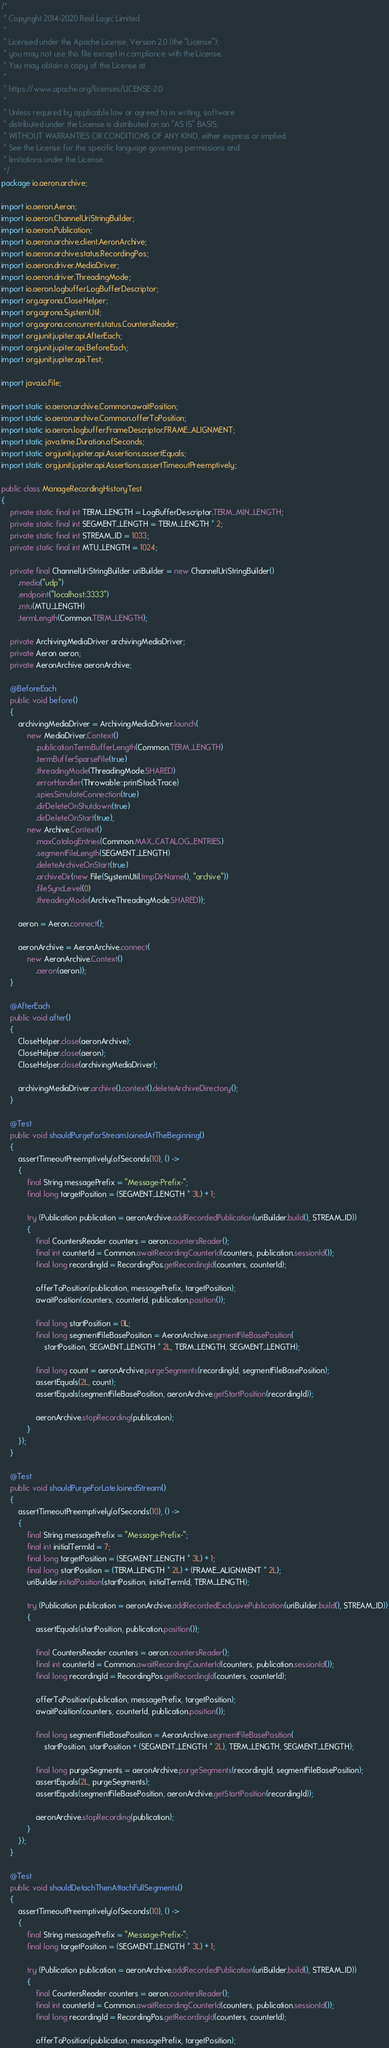Convert code to text. <code><loc_0><loc_0><loc_500><loc_500><_Java_>/*
 * Copyright 2014-2020 Real Logic Limited.
 *
 * Licensed under the Apache License, Version 2.0 (the "License");
 * you may not use this file except in compliance with the License.
 * You may obtain a copy of the License at
 *
 * https://www.apache.org/licenses/LICENSE-2.0
 *
 * Unless required by applicable law or agreed to in writing, software
 * distributed under the License is distributed on an "AS IS" BASIS,
 * WITHOUT WARRANTIES OR CONDITIONS OF ANY KIND, either express or implied.
 * See the License for the specific language governing permissions and
 * limitations under the License.
 */
package io.aeron.archive;

import io.aeron.Aeron;
import io.aeron.ChannelUriStringBuilder;
import io.aeron.Publication;
import io.aeron.archive.client.AeronArchive;
import io.aeron.archive.status.RecordingPos;
import io.aeron.driver.MediaDriver;
import io.aeron.driver.ThreadingMode;
import io.aeron.logbuffer.LogBufferDescriptor;
import org.agrona.CloseHelper;
import org.agrona.SystemUtil;
import org.agrona.concurrent.status.CountersReader;
import org.junit.jupiter.api.AfterEach;
import org.junit.jupiter.api.BeforeEach;
import org.junit.jupiter.api.Test;

import java.io.File;

import static io.aeron.archive.Common.awaitPosition;
import static io.aeron.archive.Common.offerToPosition;
import static io.aeron.logbuffer.FrameDescriptor.FRAME_ALIGNMENT;
import static java.time.Duration.ofSeconds;
import static org.junit.jupiter.api.Assertions.assertEquals;
import static org.junit.jupiter.api.Assertions.assertTimeoutPreemptively;

public class ManageRecordingHistoryTest
{
    private static final int TERM_LENGTH = LogBufferDescriptor.TERM_MIN_LENGTH;
    private static final int SEGMENT_LENGTH = TERM_LENGTH * 2;
    private static final int STREAM_ID = 1033;
    private static final int MTU_LENGTH = 1024;

    private final ChannelUriStringBuilder uriBuilder = new ChannelUriStringBuilder()
        .media("udp")
        .endpoint("localhost:3333")
        .mtu(MTU_LENGTH)
        .termLength(Common.TERM_LENGTH);

    private ArchivingMediaDriver archivingMediaDriver;
    private Aeron aeron;
    private AeronArchive aeronArchive;

    @BeforeEach
    public void before()
    {
        archivingMediaDriver = ArchivingMediaDriver.launch(
            new MediaDriver.Context()
                .publicationTermBufferLength(Common.TERM_LENGTH)
                .termBufferSparseFile(true)
                .threadingMode(ThreadingMode.SHARED)
                .errorHandler(Throwable::printStackTrace)
                .spiesSimulateConnection(true)
                .dirDeleteOnShutdown(true)
                .dirDeleteOnStart(true),
            new Archive.Context()
                .maxCatalogEntries(Common.MAX_CATALOG_ENTRIES)
                .segmentFileLength(SEGMENT_LENGTH)
                .deleteArchiveOnStart(true)
                .archiveDir(new File(SystemUtil.tmpDirName(), "archive"))
                .fileSyncLevel(0)
                .threadingMode(ArchiveThreadingMode.SHARED));

        aeron = Aeron.connect();

        aeronArchive = AeronArchive.connect(
            new AeronArchive.Context()
                .aeron(aeron));
    }

    @AfterEach
    public void after()
    {
        CloseHelper.close(aeronArchive);
        CloseHelper.close(aeron);
        CloseHelper.close(archivingMediaDriver);

        archivingMediaDriver.archive().context().deleteArchiveDirectory();
    }

    @Test
    public void shouldPurgeForStreamJoinedAtTheBeginning()
    {
        assertTimeoutPreemptively(ofSeconds(10), () ->
        {
            final String messagePrefix = "Message-Prefix-";
            final long targetPosition = (SEGMENT_LENGTH * 3L) + 1;

            try (Publication publication = aeronArchive.addRecordedPublication(uriBuilder.build(), STREAM_ID))
            {
                final CountersReader counters = aeron.countersReader();
                final int counterId = Common.awaitRecordingCounterId(counters, publication.sessionId());
                final long recordingId = RecordingPos.getRecordingId(counters, counterId);

                offerToPosition(publication, messagePrefix, targetPosition);
                awaitPosition(counters, counterId, publication.position());

                final long startPosition = 0L;
                final long segmentFileBasePosition = AeronArchive.segmentFileBasePosition(
                    startPosition, SEGMENT_LENGTH * 2L, TERM_LENGTH, SEGMENT_LENGTH);

                final long count = aeronArchive.purgeSegments(recordingId, segmentFileBasePosition);
                assertEquals(2L, count);
                assertEquals(segmentFileBasePosition, aeronArchive.getStartPosition(recordingId));

                aeronArchive.stopRecording(publication);
            }
        });
    }

    @Test
    public void shouldPurgeForLateJoinedStream()
    {
        assertTimeoutPreemptively(ofSeconds(10), () ->
        {
            final String messagePrefix = "Message-Prefix-";
            final int initialTermId = 7;
            final long targetPosition = (SEGMENT_LENGTH * 3L) + 1;
            final long startPosition = (TERM_LENGTH * 2L) + (FRAME_ALIGNMENT * 2L);
            uriBuilder.initialPosition(startPosition, initialTermId, TERM_LENGTH);

            try (Publication publication = aeronArchive.addRecordedExclusivePublication(uriBuilder.build(), STREAM_ID))
            {
                assertEquals(startPosition, publication.position());

                final CountersReader counters = aeron.countersReader();
                final int counterId = Common.awaitRecordingCounterId(counters, publication.sessionId());
                final long recordingId = RecordingPos.getRecordingId(counters, counterId);

                offerToPosition(publication, messagePrefix, targetPosition);
                awaitPosition(counters, counterId, publication.position());

                final long segmentFileBasePosition = AeronArchive.segmentFileBasePosition(
                    startPosition, startPosition + (SEGMENT_LENGTH * 2L), TERM_LENGTH, SEGMENT_LENGTH);

                final long purgeSegments = aeronArchive.purgeSegments(recordingId, segmentFileBasePosition);
                assertEquals(2L, purgeSegments);
                assertEquals(segmentFileBasePosition, aeronArchive.getStartPosition(recordingId));

                aeronArchive.stopRecording(publication);
            }
        });
    }

    @Test
    public void shouldDetachThenAttachFullSegments()
    {
        assertTimeoutPreemptively(ofSeconds(10), () ->
        {
            final String messagePrefix = "Message-Prefix-";
            final long targetPosition = (SEGMENT_LENGTH * 3L) + 1;

            try (Publication publication = aeronArchive.addRecordedPublication(uriBuilder.build(), STREAM_ID))
            {
                final CountersReader counters = aeron.countersReader();
                final int counterId = Common.awaitRecordingCounterId(counters, publication.sessionId());
                final long recordingId = RecordingPos.getRecordingId(counters, counterId);

                offerToPosition(publication, messagePrefix, targetPosition);</code> 